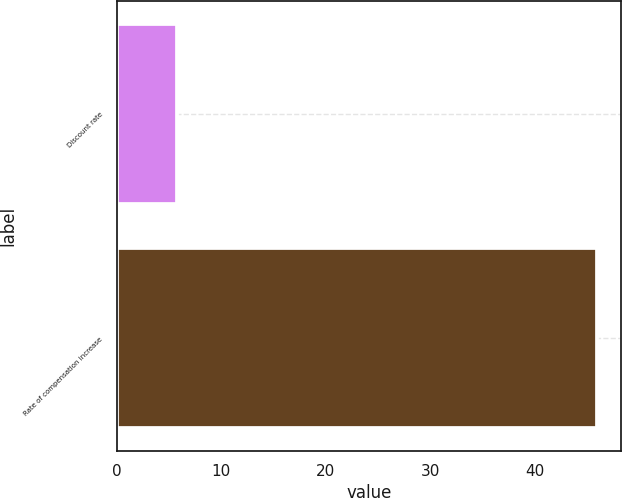Convert chart. <chart><loc_0><loc_0><loc_500><loc_500><bar_chart><fcel>Discount rate<fcel>Rate of compensation increase<nl><fcel>5.75<fcel>46<nl></chart> 